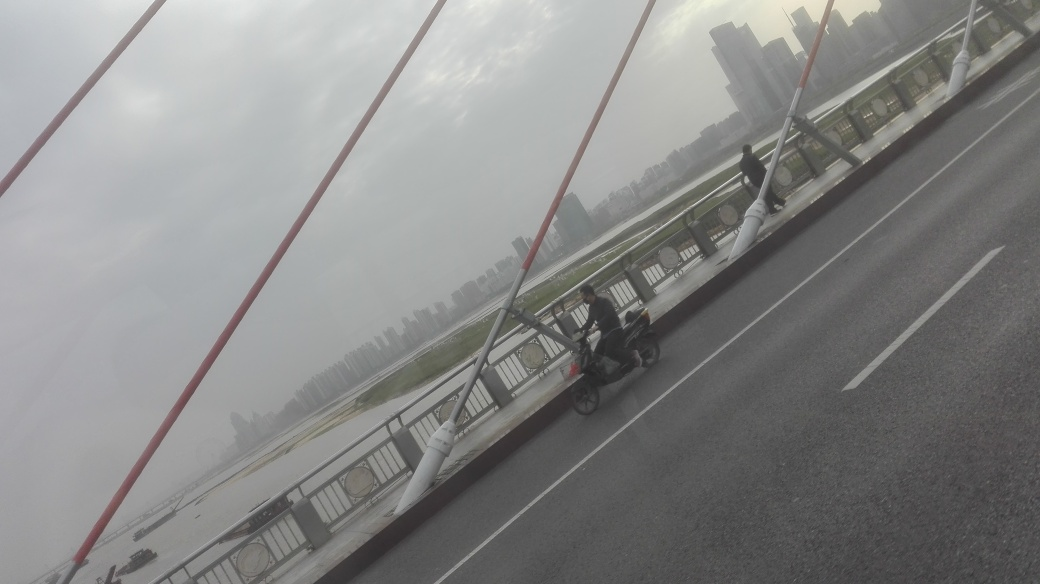What is the weather like in the image? The weather seems to be quite gloomy, with overcast skies suggesting that it could be rainy or about to rain. 